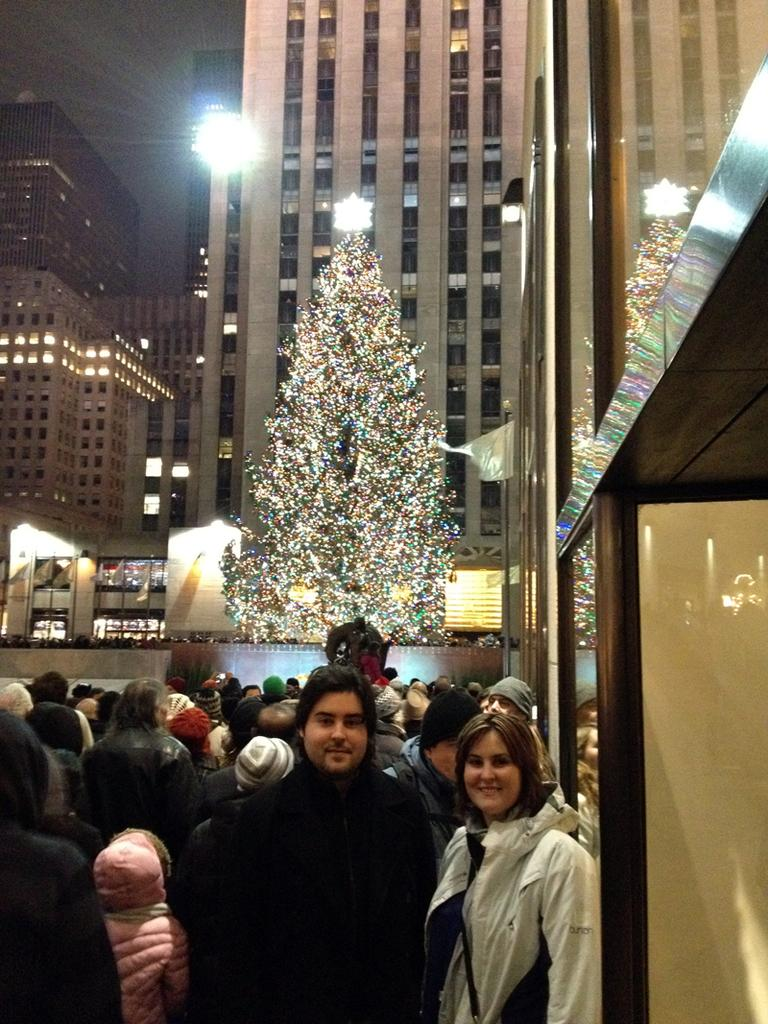Who or what can be seen in the image? There are people in the image. What is the main feature of the image? There is a big Christmas tree in the image. What else can be seen in the image besides people and the Christmas tree? There are lights and buildings in the image. What is visible in the background of the image? The sky is visible in the image. What language is being spoken by the people in the image? There is no information about the language being spoken by the people in the image. Can you see a bath in the image? There is no bath present in the image. 